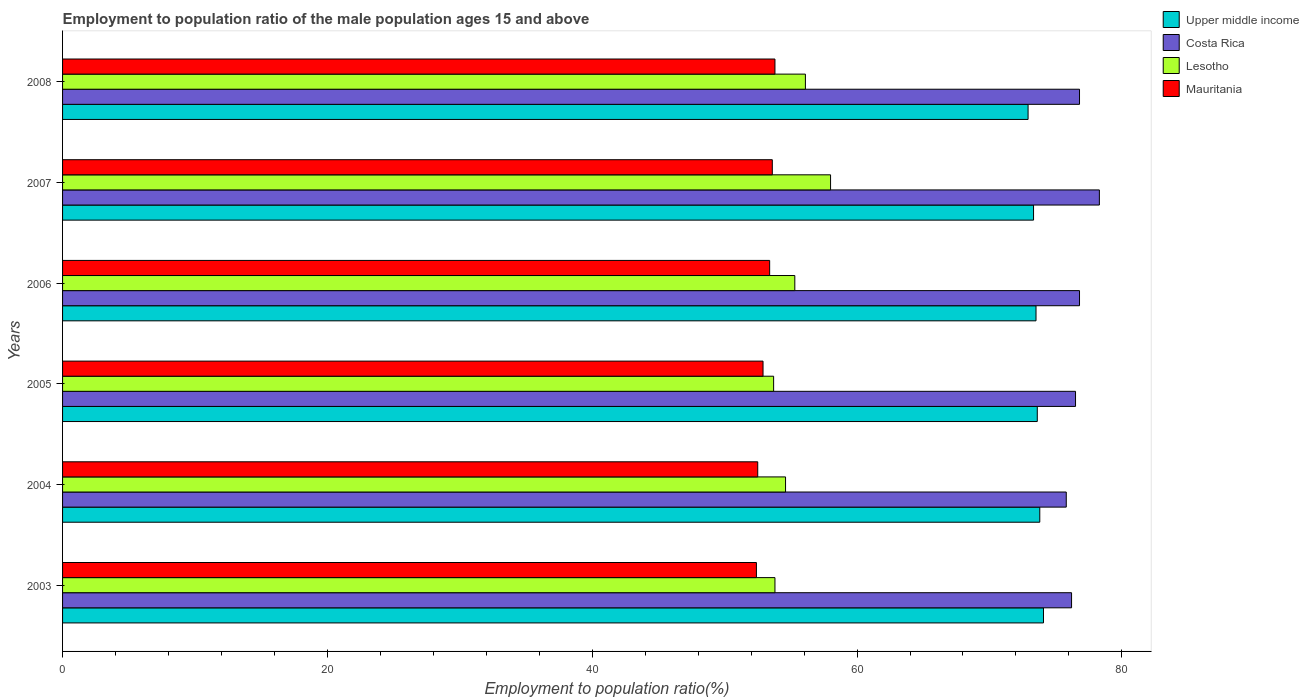How many different coloured bars are there?
Offer a very short reply. 4. How many groups of bars are there?
Your answer should be very brief. 6. Are the number of bars per tick equal to the number of legend labels?
Your answer should be compact. Yes. Are the number of bars on each tick of the Y-axis equal?
Provide a short and direct response. Yes. What is the label of the 2nd group of bars from the top?
Your answer should be very brief. 2007. In how many cases, is the number of bars for a given year not equal to the number of legend labels?
Your response must be concise. 0. What is the employment to population ratio in Lesotho in 2003?
Offer a very short reply. 53.8. Across all years, what is the maximum employment to population ratio in Upper middle income?
Provide a succinct answer. 74.08. Across all years, what is the minimum employment to population ratio in Lesotho?
Provide a short and direct response. 53.7. In which year was the employment to population ratio in Costa Rica minimum?
Your response must be concise. 2004. What is the total employment to population ratio in Costa Rica in the graph?
Provide a short and direct response. 460.4. What is the difference between the employment to population ratio in Upper middle income in 2003 and that in 2006?
Keep it short and to the point. 0.57. What is the difference between the employment to population ratio in Mauritania in 2006 and the employment to population ratio in Costa Rica in 2005?
Your answer should be compact. -23.1. What is the average employment to population ratio in Lesotho per year?
Your answer should be very brief. 55.25. In the year 2005, what is the difference between the employment to population ratio in Lesotho and employment to population ratio in Costa Rica?
Offer a very short reply. -22.8. In how many years, is the employment to population ratio in Costa Rica greater than 36 %?
Ensure brevity in your answer.  6. What is the ratio of the employment to population ratio in Upper middle income in 2006 to that in 2008?
Give a very brief answer. 1.01. Is the employment to population ratio in Lesotho in 2004 less than that in 2008?
Provide a succinct answer. Yes. Is the difference between the employment to population ratio in Lesotho in 2006 and 2007 greater than the difference between the employment to population ratio in Costa Rica in 2006 and 2007?
Provide a succinct answer. No. What is the difference between the highest and the second highest employment to population ratio in Lesotho?
Your response must be concise. 1.9. What is the difference between the highest and the lowest employment to population ratio in Upper middle income?
Offer a terse response. 1.16. Is it the case that in every year, the sum of the employment to population ratio in Mauritania and employment to population ratio in Lesotho is greater than the sum of employment to population ratio in Upper middle income and employment to population ratio in Costa Rica?
Keep it short and to the point. No. What does the 4th bar from the top in 2008 represents?
Your answer should be very brief. Upper middle income. Is it the case that in every year, the sum of the employment to population ratio in Mauritania and employment to population ratio in Lesotho is greater than the employment to population ratio in Upper middle income?
Your answer should be compact. Yes. How many bars are there?
Ensure brevity in your answer.  24. Does the graph contain grids?
Your response must be concise. No. How are the legend labels stacked?
Ensure brevity in your answer.  Vertical. What is the title of the graph?
Offer a terse response. Employment to population ratio of the male population ages 15 and above. Does "South Asia" appear as one of the legend labels in the graph?
Give a very brief answer. No. What is the label or title of the Y-axis?
Keep it short and to the point. Years. What is the Employment to population ratio(%) in Upper middle income in 2003?
Your answer should be compact. 74.08. What is the Employment to population ratio(%) of Costa Rica in 2003?
Provide a succinct answer. 76.2. What is the Employment to population ratio(%) of Lesotho in 2003?
Offer a terse response. 53.8. What is the Employment to population ratio(%) in Mauritania in 2003?
Keep it short and to the point. 52.4. What is the Employment to population ratio(%) in Upper middle income in 2004?
Provide a succinct answer. 73.8. What is the Employment to population ratio(%) of Costa Rica in 2004?
Your answer should be very brief. 75.8. What is the Employment to population ratio(%) of Lesotho in 2004?
Your answer should be compact. 54.6. What is the Employment to population ratio(%) of Mauritania in 2004?
Your response must be concise. 52.5. What is the Employment to population ratio(%) in Upper middle income in 2005?
Offer a terse response. 73.61. What is the Employment to population ratio(%) of Costa Rica in 2005?
Keep it short and to the point. 76.5. What is the Employment to population ratio(%) in Lesotho in 2005?
Give a very brief answer. 53.7. What is the Employment to population ratio(%) in Mauritania in 2005?
Your response must be concise. 52.9. What is the Employment to population ratio(%) in Upper middle income in 2006?
Keep it short and to the point. 73.51. What is the Employment to population ratio(%) in Costa Rica in 2006?
Offer a very short reply. 76.8. What is the Employment to population ratio(%) in Lesotho in 2006?
Offer a very short reply. 55.3. What is the Employment to population ratio(%) of Mauritania in 2006?
Your answer should be compact. 53.4. What is the Employment to population ratio(%) in Upper middle income in 2007?
Offer a very short reply. 73.33. What is the Employment to population ratio(%) in Costa Rica in 2007?
Offer a terse response. 78.3. What is the Employment to population ratio(%) of Lesotho in 2007?
Provide a short and direct response. 58. What is the Employment to population ratio(%) of Mauritania in 2007?
Offer a very short reply. 53.6. What is the Employment to population ratio(%) of Upper middle income in 2008?
Make the answer very short. 72.92. What is the Employment to population ratio(%) in Costa Rica in 2008?
Give a very brief answer. 76.8. What is the Employment to population ratio(%) in Lesotho in 2008?
Offer a very short reply. 56.1. What is the Employment to population ratio(%) of Mauritania in 2008?
Your response must be concise. 53.8. Across all years, what is the maximum Employment to population ratio(%) in Upper middle income?
Give a very brief answer. 74.08. Across all years, what is the maximum Employment to population ratio(%) of Costa Rica?
Provide a succinct answer. 78.3. Across all years, what is the maximum Employment to population ratio(%) in Lesotho?
Keep it short and to the point. 58. Across all years, what is the maximum Employment to population ratio(%) of Mauritania?
Offer a very short reply. 53.8. Across all years, what is the minimum Employment to population ratio(%) in Upper middle income?
Provide a short and direct response. 72.92. Across all years, what is the minimum Employment to population ratio(%) of Costa Rica?
Offer a very short reply. 75.8. Across all years, what is the minimum Employment to population ratio(%) in Lesotho?
Make the answer very short. 53.7. Across all years, what is the minimum Employment to population ratio(%) of Mauritania?
Ensure brevity in your answer.  52.4. What is the total Employment to population ratio(%) in Upper middle income in the graph?
Your answer should be compact. 441.25. What is the total Employment to population ratio(%) of Costa Rica in the graph?
Provide a short and direct response. 460.4. What is the total Employment to population ratio(%) in Lesotho in the graph?
Keep it short and to the point. 331.5. What is the total Employment to population ratio(%) of Mauritania in the graph?
Your answer should be compact. 318.6. What is the difference between the Employment to population ratio(%) of Upper middle income in 2003 and that in 2004?
Provide a succinct answer. 0.28. What is the difference between the Employment to population ratio(%) in Costa Rica in 2003 and that in 2004?
Your answer should be very brief. 0.4. What is the difference between the Employment to population ratio(%) of Lesotho in 2003 and that in 2004?
Make the answer very short. -0.8. What is the difference between the Employment to population ratio(%) of Upper middle income in 2003 and that in 2005?
Give a very brief answer. 0.47. What is the difference between the Employment to population ratio(%) in Upper middle income in 2003 and that in 2006?
Ensure brevity in your answer.  0.56. What is the difference between the Employment to population ratio(%) in Costa Rica in 2003 and that in 2006?
Ensure brevity in your answer.  -0.6. What is the difference between the Employment to population ratio(%) in Lesotho in 2003 and that in 2006?
Keep it short and to the point. -1.5. What is the difference between the Employment to population ratio(%) in Upper middle income in 2003 and that in 2007?
Ensure brevity in your answer.  0.75. What is the difference between the Employment to population ratio(%) of Costa Rica in 2003 and that in 2007?
Your answer should be compact. -2.1. What is the difference between the Employment to population ratio(%) in Lesotho in 2003 and that in 2007?
Provide a short and direct response. -4.2. What is the difference between the Employment to population ratio(%) in Upper middle income in 2003 and that in 2008?
Provide a succinct answer. 1.16. What is the difference between the Employment to population ratio(%) of Costa Rica in 2003 and that in 2008?
Ensure brevity in your answer.  -0.6. What is the difference between the Employment to population ratio(%) of Upper middle income in 2004 and that in 2005?
Your answer should be compact. 0.19. What is the difference between the Employment to population ratio(%) of Costa Rica in 2004 and that in 2005?
Offer a very short reply. -0.7. What is the difference between the Employment to population ratio(%) in Lesotho in 2004 and that in 2005?
Offer a very short reply. 0.9. What is the difference between the Employment to population ratio(%) of Mauritania in 2004 and that in 2005?
Your response must be concise. -0.4. What is the difference between the Employment to population ratio(%) of Upper middle income in 2004 and that in 2006?
Provide a succinct answer. 0.28. What is the difference between the Employment to population ratio(%) in Costa Rica in 2004 and that in 2006?
Make the answer very short. -1. What is the difference between the Employment to population ratio(%) in Lesotho in 2004 and that in 2006?
Provide a succinct answer. -0.7. What is the difference between the Employment to population ratio(%) of Mauritania in 2004 and that in 2006?
Provide a succinct answer. -0.9. What is the difference between the Employment to population ratio(%) of Upper middle income in 2004 and that in 2007?
Your answer should be compact. 0.47. What is the difference between the Employment to population ratio(%) in Costa Rica in 2004 and that in 2007?
Provide a short and direct response. -2.5. What is the difference between the Employment to population ratio(%) of Lesotho in 2004 and that in 2007?
Make the answer very short. -3.4. What is the difference between the Employment to population ratio(%) of Mauritania in 2004 and that in 2007?
Keep it short and to the point. -1.1. What is the difference between the Employment to population ratio(%) in Upper middle income in 2004 and that in 2008?
Provide a short and direct response. 0.88. What is the difference between the Employment to population ratio(%) in Mauritania in 2004 and that in 2008?
Offer a terse response. -1.3. What is the difference between the Employment to population ratio(%) in Upper middle income in 2005 and that in 2006?
Ensure brevity in your answer.  0.1. What is the difference between the Employment to population ratio(%) of Costa Rica in 2005 and that in 2006?
Offer a terse response. -0.3. What is the difference between the Employment to population ratio(%) of Lesotho in 2005 and that in 2006?
Make the answer very short. -1.6. What is the difference between the Employment to population ratio(%) in Upper middle income in 2005 and that in 2007?
Make the answer very short. 0.28. What is the difference between the Employment to population ratio(%) of Lesotho in 2005 and that in 2007?
Give a very brief answer. -4.3. What is the difference between the Employment to population ratio(%) in Upper middle income in 2005 and that in 2008?
Give a very brief answer. 0.69. What is the difference between the Employment to population ratio(%) in Costa Rica in 2005 and that in 2008?
Provide a succinct answer. -0.3. What is the difference between the Employment to population ratio(%) in Upper middle income in 2006 and that in 2007?
Make the answer very short. 0.19. What is the difference between the Employment to population ratio(%) in Costa Rica in 2006 and that in 2007?
Make the answer very short. -1.5. What is the difference between the Employment to population ratio(%) in Mauritania in 2006 and that in 2007?
Give a very brief answer. -0.2. What is the difference between the Employment to population ratio(%) in Upper middle income in 2006 and that in 2008?
Offer a terse response. 0.6. What is the difference between the Employment to population ratio(%) of Costa Rica in 2006 and that in 2008?
Provide a short and direct response. 0. What is the difference between the Employment to population ratio(%) in Lesotho in 2006 and that in 2008?
Keep it short and to the point. -0.8. What is the difference between the Employment to population ratio(%) of Mauritania in 2006 and that in 2008?
Keep it short and to the point. -0.4. What is the difference between the Employment to population ratio(%) of Upper middle income in 2007 and that in 2008?
Your answer should be compact. 0.41. What is the difference between the Employment to population ratio(%) in Costa Rica in 2007 and that in 2008?
Your response must be concise. 1.5. What is the difference between the Employment to population ratio(%) of Mauritania in 2007 and that in 2008?
Give a very brief answer. -0.2. What is the difference between the Employment to population ratio(%) of Upper middle income in 2003 and the Employment to population ratio(%) of Costa Rica in 2004?
Keep it short and to the point. -1.72. What is the difference between the Employment to population ratio(%) in Upper middle income in 2003 and the Employment to population ratio(%) in Lesotho in 2004?
Your answer should be very brief. 19.48. What is the difference between the Employment to population ratio(%) in Upper middle income in 2003 and the Employment to population ratio(%) in Mauritania in 2004?
Your response must be concise. 21.58. What is the difference between the Employment to population ratio(%) in Costa Rica in 2003 and the Employment to population ratio(%) in Lesotho in 2004?
Offer a very short reply. 21.6. What is the difference between the Employment to population ratio(%) of Costa Rica in 2003 and the Employment to population ratio(%) of Mauritania in 2004?
Ensure brevity in your answer.  23.7. What is the difference between the Employment to population ratio(%) in Upper middle income in 2003 and the Employment to population ratio(%) in Costa Rica in 2005?
Ensure brevity in your answer.  -2.42. What is the difference between the Employment to population ratio(%) in Upper middle income in 2003 and the Employment to population ratio(%) in Lesotho in 2005?
Offer a terse response. 20.38. What is the difference between the Employment to population ratio(%) in Upper middle income in 2003 and the Employment to population ratio(%) in Mauritania in 2005?
Provide a succinct answer. 21.18. What is the difference between the Employment to population ratio(%) in Costa Rica in 2003 and the Employment to population ratio(%) in Lesotho in 2005?
Give a very brief answer. 22.5. What is the difference between the Employment to population ratio(%) in Costa Rica in 2003 and the Employment to population ratio(%) in Mauritania in 2005?
Your response must be concise. 23.3. What is the difference between the Employment to population ratio(%) in Lesotho in 2003 and the Employment to population ratio(%) in Mauritania in 2005?
Make the answer very short. 0.9. What is the difference between the Employment to population ratio(%) of Upper middle income in 2003 and the Employment to population ratio(%) of Costa Rica in 2006?
Provide a succinct answer. -2.72. What is the difference between the Employment to population ratio(%) of Upper middle income in 2003 and the Employment to population ratio(%) of Lesotho in 2006?
Give a very brief answer. 18.78. What is the difference between the Employment to population ratio(%) in Upper middle income in 2003 and the Employment to population ratio(%) in Mauritania in 2006?
Ensure brevity in your answer.  20.68. What is the difference between the Employment to population ratio(%) of Costa Rica in 2003 and the Employment to population ratio(%) of Lesotho in 2006?
Ensure brevity in your answer.  20.9. What is the difference between the Employment to population ratio(%) of Costa Rica in 2003 and the Employment to population ratio(%) of Mauritania in 2006?
Make the answer very short. 22.8. What is the difference between the Employment to population ratio(%) in Lesotho in 2003 and the Employment to population ratio(%) in Mauritania in 2006?
Provide a succinct answer. 0.4. What is the difference between the Employment to population ratio(%) of Upper middle income in 2003 and the Employment to population ratio(%) of Costa Rica in 2007?
Offer a terse response. -4.22. What is the difference between the Employment to population ratio(%) of Upper middle income in 2003 and the Employment to population ratio(%) of Lesotho in 2007?
Offer a terse response. 16.08. What is the difference between the Employment to population ratio(%) of Upper middle income in 2003 and the Employment to population ratio(%) of Mauritania in 2007?
Your answer should be compact. 20.48. What is the difference between the Employment to population ratio(%) in Costa Rica in 2003 and the Employment to population ratio(%) in Mauritania in 2007?
Your answer should be compact. 22.6. What is the difference between the Employment to population ratio(%) of Lesotho in 2003 and the Employment to population ratio(%) of Mauritania in 2007?
Ensure brevity in your answer.  0.2. What is the difference between the Employment to population ratio(%) in Upper middle income in 2003 and the Employment to population ratio(%) in Costa Rica in 2008?
Your answer should be very brief. -2.72. What is the difference between the Employment to population ratio(%) of Upper middle income in 2003 and the Employment to population ratio(%) of Lesotho in 2008?
Make the answer very short. 17.98. What is the difference between the Employment to population ratio(%) in Upper middle income in 2003 and the Employment to population ratio(%) in Mauritania in 2008?
Your response must be concise. 20.28. What is the difference between the Employment to population ratio(%) of Costa Rica in 2003 and the Employment to population ratio(%) of Lesotho in 2008?
Ensure brevity in your answer.  20.1. What is the difference between the Employment to population ratio(%) of Costa Rica in 2003 and the Employment to population ratio(%) of Mauritania in 2008?
Provide a short and direct response. 22.4. What is the difference between the Employment to population ratio(%) in Upper middle income in 2004 and the Employment to population ratio(%) in Costa Rica in 2005?
Your answer should be compact. -2.7. What is the difference between the Employment to population ratio(%) of Upper middle income in 2004 and the Employment to population ratio(%) of Lesotho in 2005?
Provide a short and direct response. 20.1. What is the difference between the Employment to population ratio(%) of Upper middle income in 2004 and the Employment to population ratio(%) of Mauritania in 2005?
Your response must be concise. 20.9. What is the difference between the Employment to population ratio(%) of Costa Rica in 2004 and the Employment to population ratio(%) of Lesotho in 2005?
Ensure brevity in your answer.  22.1. What is the difference between the Employment to population ratio(%) in Costa Rica in 2004 and the Employment to population ratio(%) in Mauritania in 2005?
Offer a very short reply. 22.9. What is the difference between the Employment to population ratio(%) of Upper middle income in 2004 and the Employment to population ratio(%) of Costa Rica in 2006?
Keep it short and to the point. -3. What is the difference between the Employment to population ratio(%) in Upper middle income in 2004 and the Employment to population ratio(%) in Lesotho in 2006?
Keep it short and to the point. 18.5. What is the difference between the Employment to population ratio(%) of Upper middle income in 2004 and the Employment to population ratio(%) of Mauritania in 2006?
Make the answer very short. 20.4. What is the difference between the Employment to population ratio(%) of Costa Rica in 2004 and the Employment to population ratio(%) of Lesotho in 2006?
Your answer should be very brief. 20.5. What is the difference between the Employment to population ratio(%) of Costa Rica in 2004 and the Employment to population ratio(%) of Mauritania in 2006?
Give a very brief answer. 22.4. What is the difference between the Employment to population ratio(%) of Lesotho in 2004 and the Employment to population ratio(%) of Mauritania in 2006?
Your response must be concise. 1.2. What is the difference between the Employment to population ratio(%) of Upper middle income in 2004 and the Employment to population ratio(%) of Costa Rica in 2007?
Offer a very short reply. -4.5. What is the difference between the Employment to population ratio(%) of Upper middle income in 2004 and the Employment to population ratio(%) of Lesotho in 2007?
Make the answer very short. 15.8. What is the difference between the Employment to population ratio(%) in Upper middle income in 2004 and the Employment to population ratio(%) in Mauritania in 2007?
Provide a succinct answer. 20.2. What is the difference between the Employment to population ratio(%) in Costa Rica in 2004 and the Employment to population ratio(%) in Lesotho in 2007?
Your response must be concise. 17.8. What is the difference between the Employment to population ratio(%) in Lesotho in 2004 and the Employment to population ratio(%) in Mauritania in 2007?
Give a very brief answer. 1. What is the difference between the Employment to population ratio(%) in Upper middle income in 2004 and the Employment to population ratio(%) in Costa Rica in 2008?
Give a very brief answer. -3. What is the difference between the Employment to population ratio(%) in Upper middle income in 2004 and the Employment to population ratio(%) in Lesotho in 2008?
Give a very brief answer. 17.7. What is the difference between the Employment to population ratio(%) of Upper middle income in 2004 and the Employment to population ratio(%) of Mauritania in 2008?
Provide a short and direct response. 20. What is the difference between the Employment to population ratio(%) in Costa Rica in 2004 and the Employment to population ratio(%) in Lesotho in 2008?
Offer a terse response. 19.7. What is the difference between the Employment to population ratio(%) in Costa Rica in 2004 and the Employment to population ratio(%) in Mauritania in 2008?
Provide a succinct answer. 22. What is the difference between the Employment to population ratio(%) of Upper middle income in 2005 and the Employment to population ratio(%) of Costa Rica in 2006?
Make the answer very short. -3.19. What is the difference between the Employment to population ratio(%) of Upper middle income in 2005 and the Employment to population ratio(%) of Lesotho in 2006?
Give a very brief answer. 18.31. What is the difference between the Employment to population ratio(%) in Upper middle income in 2005 and the Employment to population ratio(%) in Mauritania in 2006?
Give a very brief answer. 20.21. What is the difference between the Employment to population ratio(%) in Costa Rica in 2005 and the Employment to population ratio(%) in Lesotho in 2006?
Offer a terse response. 21.2. What is the difference between the Employment to population ratio(%) in Costa Rica in 2005 and the Employment to population ratio(%) in Mauritania in 2006?
Give a very brief answer. 23.1. What is the difference between the Employment to population ratio(%) of Lesotho in 2005 and the Employment to population ratio(%) of Mauritania in 2006?
Offer a very short reply. 0.3. What is the difference between the Employment to population ratio(%) of Upper middle income in 2005 and the Employment to population ratio(%) of Costa Rica in 2007?
Offer a very short reply. -4.69. What is the difference between the Employment to population ratio(%) of Upper middle income in 2005 and the Employment to population ratio(%) of Lesotho in 2007?
Your response must be concise. 15.61. What is the difference between the Employment to population ratio(%) in Upper middle income in 2005 and the Employment to population ratio(%) in Mauritania in 2007?
Offer a terse response. 20.01. What is the difference between the Employment to population ratio(%) of Costa Rica in 2005 and the Employment to population ratio(%) of Lesotho in 2007?
Give a very brief answer. 18.5. What is the difference between the Employment to population ratio(%) of Costa Rica in 2005 and the Employment to population ratio(%) of Mauritania in 2007?
Give a very brief answer. 22.9. What is the difference between the Employment to population ratio(%) in Lesotho in 2005 and the Employment to population ratio(%) in Mauritania in 2007?
Offer a very short reply. 0.1. What is the difference between the Employment to population ratio(%) of Upper middle income in 2005 and the Employment to population ratio(%) of Costa Rica in 2008?
Offer a very short reply. -3.19. What is the difference between the Employment to population ratio(%) in Upper middle income in 2005 and the Employment to population ratio(%) in Lesotho in 2008?
Provide a succinct answer. 17.51. What is the difference between the Employment to population ratio(%) in Upper middle income in 2005 and the Employment to population ratio(%) in Mauritania in 2008?
Offer a terse response. 19.81. What is the difference between the Employment to population ratio(%) of Costa Rica in 2005 and the Employment to population ratio(%) of Lesotho in 2008?
Your answer should be very brief. 20.4. What is the difference between the Employment to population ratio(%) of Costa Rica in 2005 and the Employment to population ratio(%) of Mauritania in 2008?
Provide a succinct answer. 22.7. What is the difference between the Employment to population ratio(%) of Lesotho in 2005 and the Employment to population ratio(%) of Mauritania in 2008?
Give a very brief answer. -0.1. What is the difference between the Employment to population ratio(%) of Upper middle income in 2006 and the Employment to population ratio(%) of Costa Rica in 2007?
Offer a terse response. -4.79. What is the difference between the Employment to population ratio(%) in Upper middle income in 2006 and the Employment to population ratio(%) in Lesotho in 2007?
Give a very brief answer. 15.51. What is the difference between the Employment to population ratio(%) in Upper middle income in 2006 and the Employment to population ratio(%) in Mauritania in 2007?
Your answer should be compact. 19.91. What is the difference between the Employment to population ratio(%) of Costa Rica in 2006 and the Employment to population ratio(%) of Lesotho in 2007?
Your response must be concise. 18.8. What is the difference between the Employment to population ratio(%) in Costa Rica in 2006 and the Employment to population ratio(%) in Mauritania in 2007?
Your response must be concise. 23.2. What is the difference between the Employment to population ratio(%) of Upper middle income in 2006 and the Employment to population ratio(%) of Costa Rica in 2008?
Provide a succinct answer. -3.29. What is the difference between the Employment to population ratio(%) in Upper middle income in 2006 and the Employment to population ratio(%) in Lesotho in 2008?
Provide a succinct answer. 17.41. What is the difference between the Employment to population ratio(%) in Upper middle income in 2006 and the Employment to population ratio(%) in Mauritania in 2008?
Provide a short and direct response. 19.71. What is the difference between the Employment to population ratio(%) in Costa Rica in 2006 and the Employment to population ratio(%) in Lesotho in 2008?
Provide a succinct answer. 20.7. What is the difference between the Employment to population ratio(%) of Upper middle income in 2007 and the Employment to population ratio(%) of Costa Rica in 2008?
Ensure brevity in your answer.  -3.47. What is the difference between the Employment to population ratio(%) in Upper middle income in 2007 and the Employment to population ratio(%) in Lesotho in 2008?
Give a very brief answer. 17.23. What is the difference between the Employment to population ratio(%) of Upper middle income in 2007 and the Employment to population ratio(%) of Mauritania in 2008?
Provide a short and direct response. 19.53. What is the difference between the Employment to population ratio(%) of Costa Rica in 2007 and the Employment to population ratio(%) of Lesotho in 2008?
Provide a succinct answer. 22.2. What is the average Employment to population ratio(%) of Upper middle income per year?
Keep it short and to the point. 73.54. What is the average Employment to population ratio(%) in Costa Rica per year?
Your response must be concise. 76.73. What is the average Employment to population ratio(%) in Lesotho per year?
Give a very brief answer. 55.25. What is the average Employment to population ratio(%) of Mauritania per year?
Make the answer very short. 53.1. In the year 2003, what is the difference between the Employment to population ratio(%) in Upper middle income and Employment to population ratio(%) in Costa Rica?
Your answer should be compact. -2.12. In the year 2003, what is the difference between the Employment to population ratio(%) of Upper middle income and Employment to population ratio(%) of Lesotho?
Make the answer very short. 20.28. In the year 2003, what is the difference between the Employment to population ratio(%) in Upper middle income and Employment to population ratio(%) in Mauritania?
Make the answer very short. 21.68. In the year 2003, what is the difference between the Employment to population ratio(%) in Costa Rica and Employment to population ratio(%) in Lesotho?
Your response must be concise. 22.4. In the year 2003, what is the difference between the Employment to population ratio(%) in Costa Rica and Employment to population ratio(%) in Mauritania?
Your answer should be compact. 23.8. In the year 2004, what is the difference between the Employment to population ratio(%) of Upper middle income and Employment to population ratio(%) of Costa Rica?
Keep it short and to the point. -2. In the year 2004, what is the difference between the Employment to population ratio(%) of Upper middle income and Employment to population ratio(%) of Lesotho?
Offer a very short reply. 19.2. In the year 2004, what is the difference between the Employment to population ratio(%) in Upper middle income and Employment to population ratio(%) in Mauritania?
Your response must be concise. 21.3. In the year 2004, what is the difference between the Employment to population ratio(%) in Costa Rica and Employment to population ratio(%) in Lesotho?
Keep it short and to the point. 21.2. In the year 2004, what is the difference between the Employment to population ratio(%) of Costa Rica and Employment to population ratio(%) of Mauritania?
Your response must be concise. 23.3. In the year 2004, what is the difference between the Employment to population ratio(%) in Lesotho and Employment to population ratio(%) in Mauritania?
Your answer should be compact. 2.1. In the year 2005, what is the difference between the Employment to population ratio(%) of Upper middle income and Employment to population ratio(%) of Costa Rica?
Offer a terse response. -2.89. In the year 2005, what is the difference between the Employment to population ratio(%) in Upper middle income and Employment to population ratio(%) in Lesotho?
Provide a short and direct response. 19.91. In the year 2005, what is the difference between the Employment to population ratio(%) of Upper middle income and Employment to population ratio(%) of Mauritania?
Make the answer very short. 20.71. In the year 2005, what is the difference between the Employment to population ratio(%) of Costa Rica and Employment to population ratio(%) of Lesotho?
Give a very brief answer. 22.8. In the year 2005, what is the difference between the Employment to population ratio(%) of Costa Rica and Employment to population ratio(%) of Mauritania?
Give a very brief answer. 23.6. In the year 2006, what is the difference between the Employment to population ratio(%) of Upper middle income and Employment to population ratio(%) of Costa Rica?
Provide a succinct answer. -3.29. In the year 2006, what is the difference between the Employment to population ratio(%) of Upper middle income and Employment to population ratio(%) of Lesotho?
Offer a very short reply. 18.21. In the year 2006, what is the difference between the Employment to population ratio(%) of Upper middle income and Employment to population ratio(%) of Mauritania?
Ensure brevity in your answer.  20.11. In the year 2006, what is the difference between the Employment to population ratio(%) in Costa Rica and Employment to population ratio(%) in Lesotho?
Make the answer very short. 21.5. In the year 2006, what is the difference between the Employment to population ratio(%) in Costa Rica and Employment to population ratio(%) in Mauritania?
Offer a very short reply. 23.4. In the year 2006, what is the difference between the Employment to population ratio(%) in Lesotho and Employment to population ratio(%) in Mauritania?
Your answer should be compact. 1.9. In the year 2007, what is the difference between the Employment to population ratio(%) in Upper middle income and Employment to population ratio(%) in Costa Rica?
Provide a succinct answer. -4.97. In the year 2007, what is the difference between the Employment to population ratio(%) of Upper middle income and Employment to population ratio(%) of Lesotho?
Ensure brevity in your answer.  15.33. In the year 2007, what is the difference between the Employment to population ratio(%) in Upper middle income and Employment to population ratio(%) in Mauritania?
Ensure brevity in your answer.  19.73. In the year 2007, what is the difference between the Employment to population ratio(%) in Costa Rica and Employment to population ratio(%) in Lesotho?
Provide a succinct answer. 20.3. In the year 2007, what is the difference between the Employment to population ratio(%) in Costa Rica and Employment to population ratio(%) in Mauritania?
Keep it short and to the point. 24.7. In the year 2007, what is the difference between the Employment to population ratio(%) in Lesotho and Employment to population ratio(%) in Mauritania?
Keep it short and to the point. 4.4. In the year 2008, what is the difference between the Employment to population ratio(%) of Upper middle income and Employment to population ratio(%) of Costa Rica?
Keep it short and to the point. -3.88. In the year 2008, what is the difference between the Employment to population ratio(%) of Upper middle income and Employment to population ratio(%) of Lesotho?
Offer a very short reply. 16.82. In the year 2008, what is the difference between the Employment to population ratio(%) of Upper middle income and Employment to population ratio(%) of Mauritania?
Your response must be concise. 19.12. In the year 2008, what is the difference between the Employment to population ratio(%) of Costa Rica and Employment to population ratio(%) of Lesotho?
Make the answer very short. 20.7. In the year 2008, what is the difference between the Employment to population ratio(%) in Lesotho and Employment to population ratio(%) in Mauritania?
Offer a very short reply. 2.3. What is the ratio of the Employment to population ratio(%) in Lesotho in 2003 to that in 2004?
Your answer should be very brief. 0.99. What is the ratio of the Employment to population ratio(%) in Upper middle income in 2003 to that in 2005?
Offer a terse response. 1.01. What is the ratio of the Employment to population ratio(%) in Mauritania in 2003 to that in 2005?
Ensure brevity in your answer.  0.99. What is the ratio of the Employment to population ratio(%) in Upper middle income in 2003 to that in 2006?
Give a very brief answer. 1.01. What is the ratio of the Employment to population ratio(%) in Costa Rica in 2003 to that in 2006?
Give a very brief answer. 0.99. What is the ratio of the Employment to population ratio(%) of Lesotho in 2003 to that in 2006?
Make the answer very short. 0.97. What is the ratio of the Employment to population ratio(%) in Mauritania in 2003 to that in 2006?
Provide a short and direct response. 0.98. What is the ratio of the Employment to population ratio(%) of Upper middle income in 2003 to that in 2007?
Give a very brief answer. 1.01. What is the ratio of the Employment to population ratio(%) of Costa Rica in 2003 to that in 2007?
Offer a very short reply. 0.97. What is the ratio of the Employment to population ratio(%) of Lesotho in 2003 to that in 2007?
Your response must be concise. 0.93. What is the ratio of the Employment to population ratio(%) in Mauritania in 2003 to that in 2007?
Offer a terse response. 0.98. What is the ratio of the Employment to population ratio(%) of Upper middle income in 2003 to that in 2008?
Provide a succinct answer. 1.02. What is the ratio of the Employment to population ratio(%) in Costa Rica in 2003 to that in 2008?
Give a very brief answer. 0.99. What is the ratio of the Employment to population ratio(%) in Lesotho in 2003 to that in 2008?
Provide a succinct answer. 0.96. What is the ratio of the Employment to population ratio(%) of Costa Rica in 2004 to that in 2005?
Offer a terse response. 0.99. What is the ratio of the Employment to population ratio(%) of Lesotho in 2004 to that in 2005?
Your answer should be very brief. 1.02. What is the ratio of the Employment to population ratio(%) of Lesotho in 2004 to that in 2006?
Provide a succinct answer. 0.99. What is the ratio of the Employment to population ratio(%) in Mauritania in 2004 to that in 2006?
Keep it short and to the point. 0.98. What is the ratio of the Employment to population ratio(%) in Upper middle income in 2004 to that in 2007?
Make the answer very short. 1.01. What is the ratio of the Employment to population ratio(%) of Costa Rica in 2004 to that in 2007?
Your response must be concise. 0.97. What is the ratio of the Employment to population ratio(%) of Lesotho in 2004 to that in 2007?
Provide a short and direct response. 0.94. What is the ratio of the Employment to population ratio(%) in Mauritania in 2004 to that in 2007?
Ensure brevity in your answer.  0.98. What is the ratio of the Employment to population ratio(%) of Upper middle income in 2004 to that in 2008?
Offer a terse response. 1.01. What is the ratio of the Employment to population ratio(%) in Costa Rica in 2004 to that in 2008?
Your answer should be compact. 0.99. What is the ratio of the Employment to population ratio(%) in Lesotho in 2004 to that in 2008?
Keep it short and to the point. 0.97. What is the ratio of the Employment to population ratio(%) in Mauritania in 2004 to that in 2008?
Your answer should be compact. 0.98. What is the ratio of the Employment to population ratio(%) of Lesotho in 2005 to that in 2006?
Your answer should be very brief. 0.97. What is the ratio of the Employment to population ratio(%) of Mauritania in 2005 to that in 2006?
Offer a terse response. 0.99. What is the ratio of the Employment to population ratio(%) of Lesotho in 2005 to that in 2007?
Your answer should be very brief. 0.93. What is the ratio of the Employment to population ratio(%) in Mauritania in 2005 to that in 2007?
Give a very brief answer. 0.99. What is the ratio of the Employment to population ratio(%) in Upper middle income in 2005 to that in 2008?
Ensure brevity in your answer.  1.01. What is the ratio of the Employment to population ratio(%) of Lesotho in 2005 to that in 2008?
Your answer should be compact. 0.96. What is the ratio of the Employment to population ratio(%) in Mauritania in 2005 to that in 2008?
Make the answer very short. 0.98. What is the ratio of the Employment to population ratio(%) of Upper middle income in 2006 to that in 2007?
Make the answer very short. 1. What is the ratio of the Employment to population ratio(%) of Costa Rica in 2006 to that in 2007?
Your answer should be very brief. 0.98. What is the ratio of the Employment to population ratio(%) of Lesotho in 2006 to that in 2007?
Offer a very short reply. 0.95. What is the ratio of the Employment to population ratio(%) of Upper middle income in 2006 to that in 2008?
Offer a terse response. 1.01. What is the ratio of the Employment to population ratio(%) of Costa Rica in 2006 to that in 2008?
Your response must be concise. 1. What is the ratio of the Employment to population ratio(%) of Lesotho in 2006 to that in 2008?
Provide a short and direct response. 0.99. What is the ratio of the Employment to population ratio(%) of Mauritania in 2006 to that in 2008?
Ensure brevity in your answer.  0.99. What is the ratio of the Employment to population ratio(%) in Costa Rica in 2007 to that in 2008?
Offer a terse response. 1.02. What is the ratio of the Employment to population ratio(%) in Lesotho in 2007 to that in 2008?
Your response must be concise. 1.03. What is the ratio of the Employment to population ratio(%) in Mauritania in 2007 to that in 2008?
Offer a very short reply. 1. What is the difference between the highest and the second highest Employment to population ratio(%) in Upper middle income?
Provide a succinct answer. 0.28. What is the difference between the highest and the second highest Employment to population ratio(%) in Costa Rica?
Your answer should be very brief. 1.5. What is the difference between the highest and the second highest Employment to population ratio(%) of Lesotho?
Give a very brief answer. 1.9. What is the difference between the highest and the second highest Employment to population ratio(%) of Mauritania?
Your response must be concise. 0.2. What is the difference between the highest and the lowest Employment to population ratio(%) of Upper middle income?
Your answer should be very brief. 1.16. What is the difference between the highest and the lowest Employment to population ratio(%) in Costa Rica?
Keep it short and to the point. 2.5. 